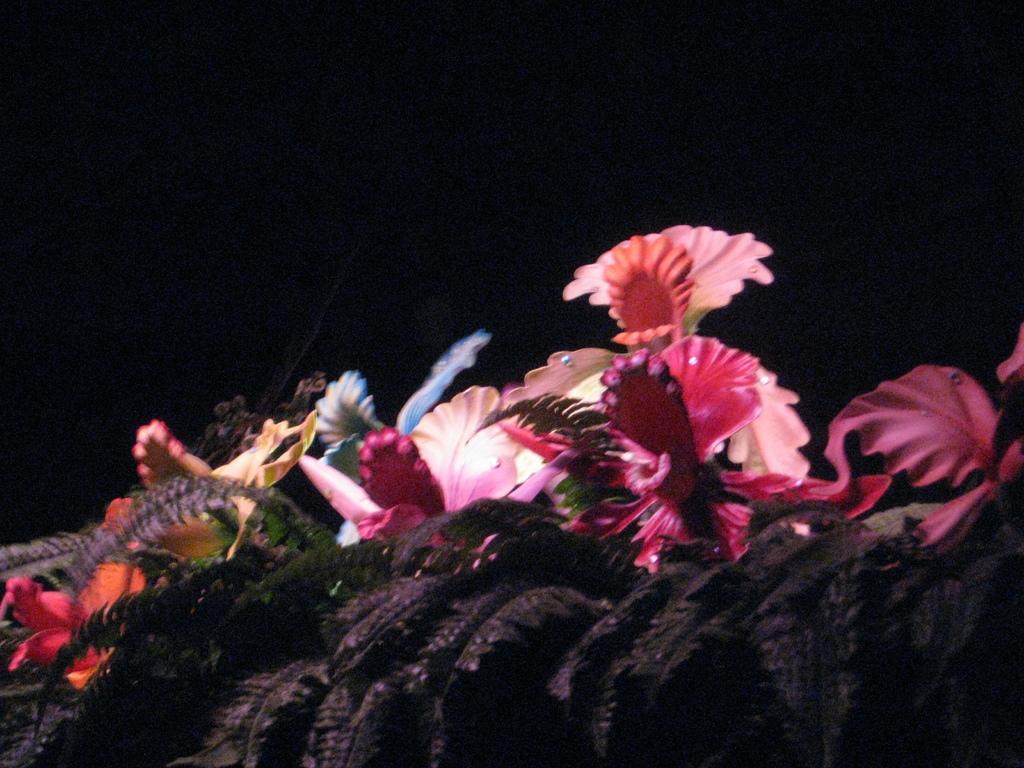In one or two sentences, can you explain what this image depicts? As we can see in the image in the front there are flowers and the background is dark. 